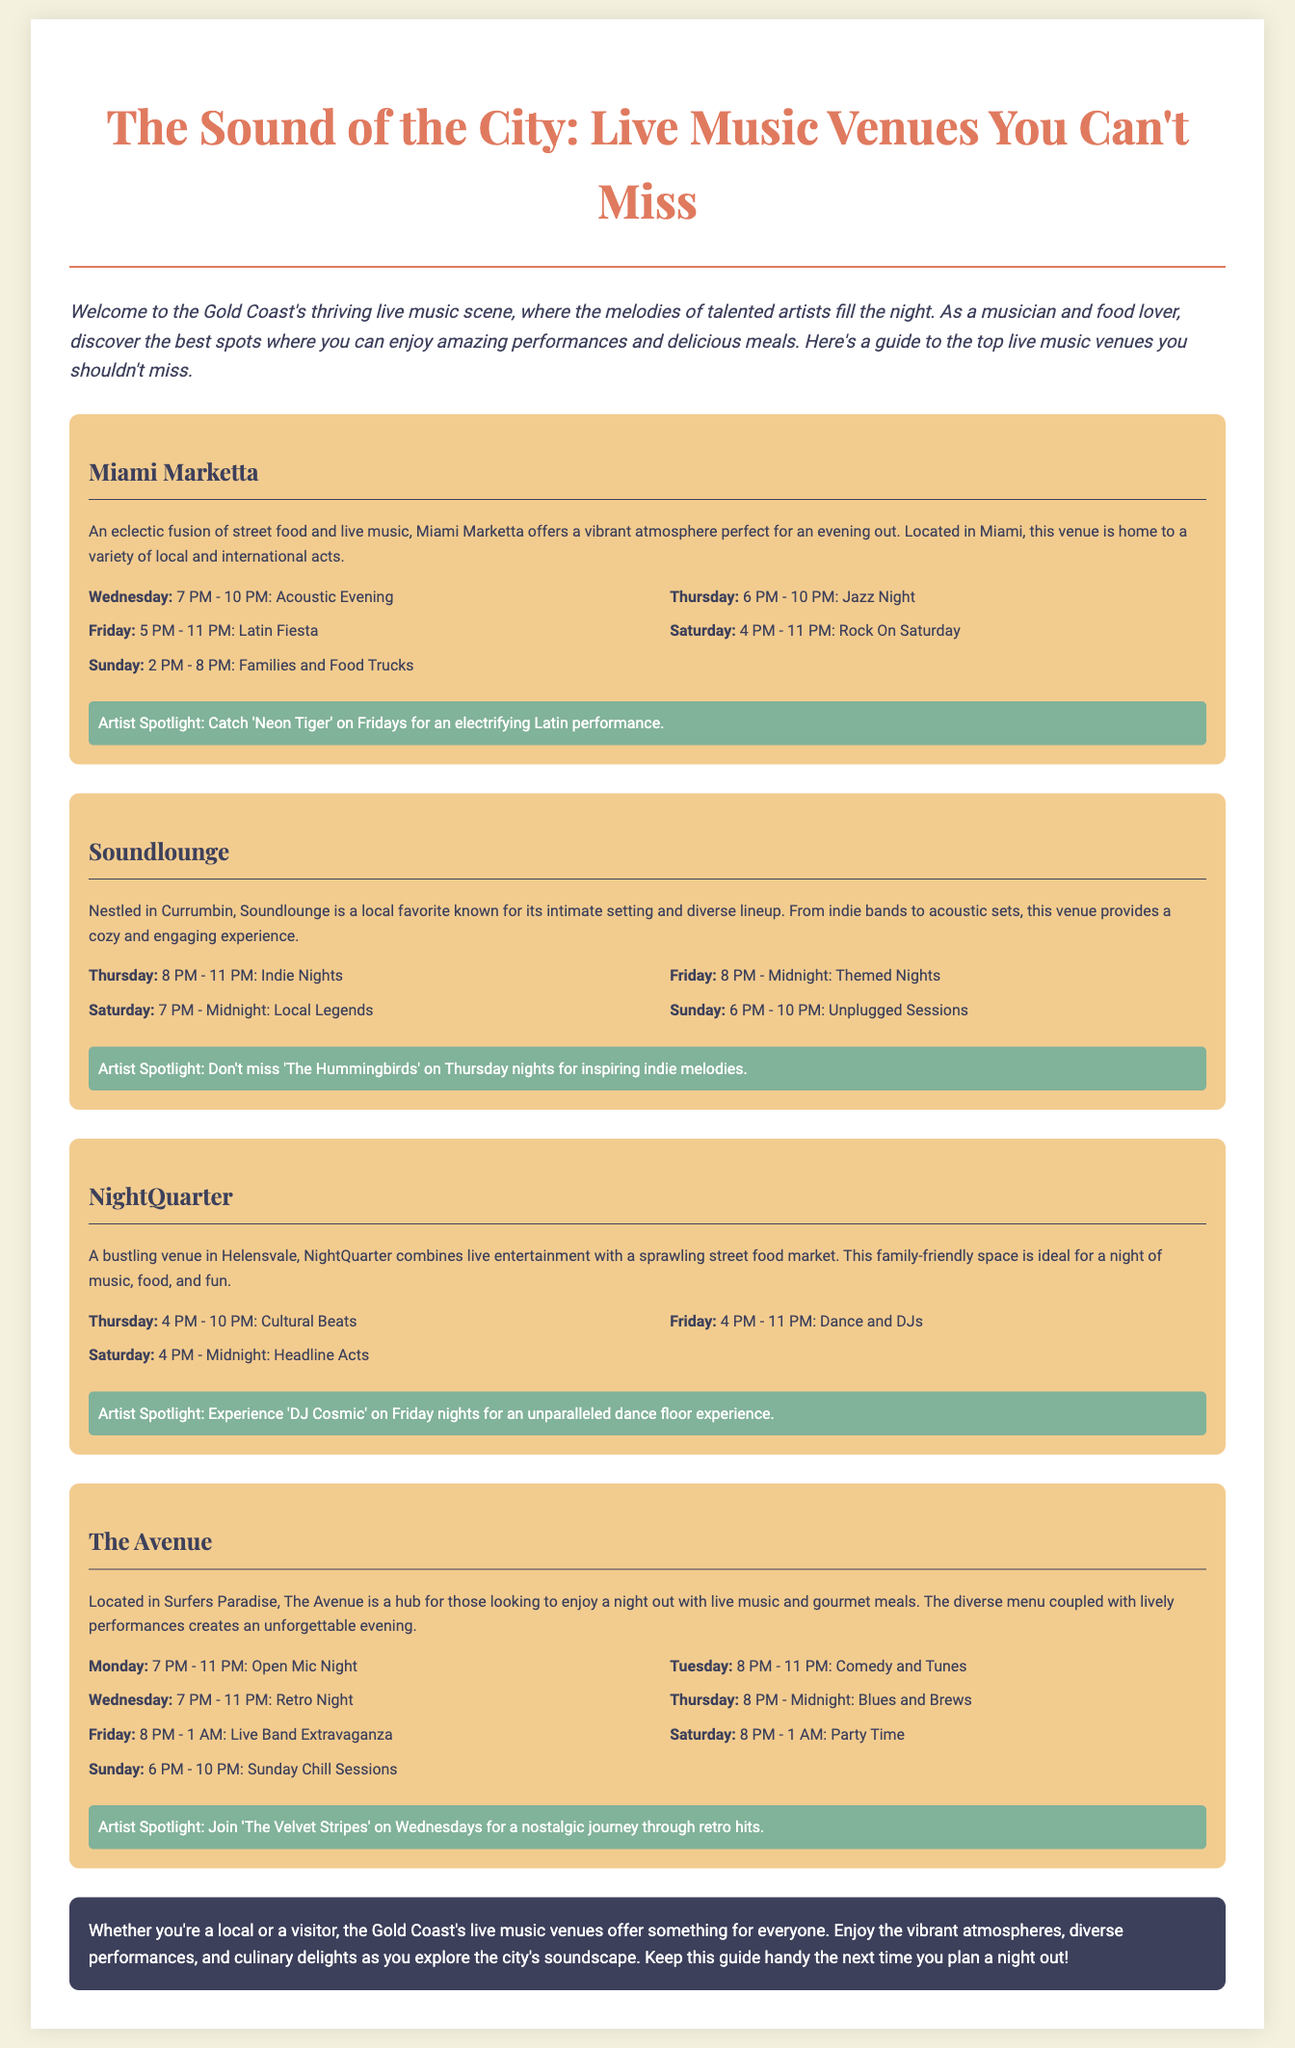What is the title of the document? The title is prominently displayed at the top of the document and reflects the main theme of the content.
Answer: The Sound of the City: Live Music Venues You Can't Miss What is the name of the venue that hosts Acoustic Evenings on Wednesdays? The schedule for the Acoustic Evening is specifically mentioned in the Miami Marketta section.
Answer: Miami Marketta Which artist performs on Friday nights at NightQuarter? The artist is specified in the corresponding spotlight section for NightQuarter on Friday.
Answer: DJ Cosmic How many days a week does The Avenue host live music events? The schedule outlined for The Avenue shows events listed for each day of the week.
Answer: Seven What kind of atmosphere does Soundlounge provide? The description of Soundlounge highlights its setting and the experience it offers.
Answer: Cozy and engaging What genre of music can be enjoyed on Thursdays at Miami Marketta? The schedule details for Miami Marketta state the specific event that occurs on Thursdays.
Answer: Jazz Night How late does Latin Fiesta at Miami Marketta last on Fridays? The schedule lists the specific ending time for the Latin Fiesta on Fridays.
Answer: 11 PM What type of nights does The Avenue host on Tuesdays? The schedule for The Avenue includes a specific genre/theme for Tuesday nights.
Answer: Comedy and Tunes 